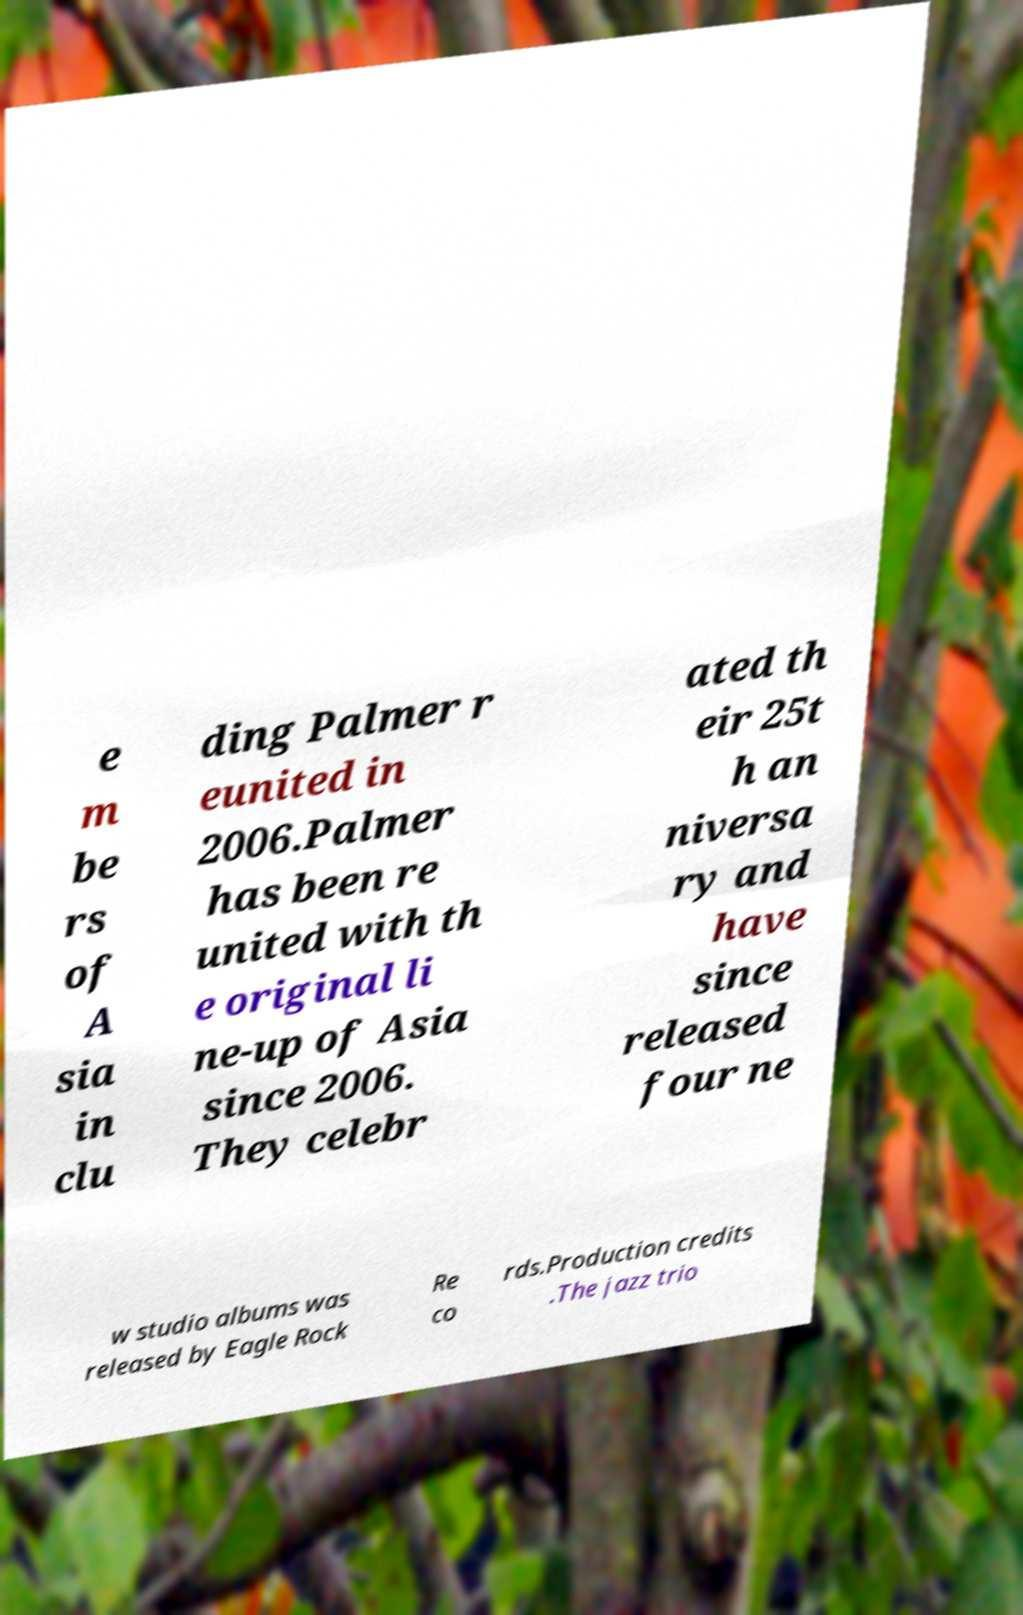There's text embedded in this image that I need extracted. Can you transcribe it verbatim? e m be rs of A sia in clu ding Palmer r eunited in 2006.Palmer has been re united with th e original li ne-up of Asia since 2006. They celebr ated th eir 25t h an niversa ry and have since released four ne w studio albums was released by Eagle Rock Re co rds.Production credits .The jazz trio 